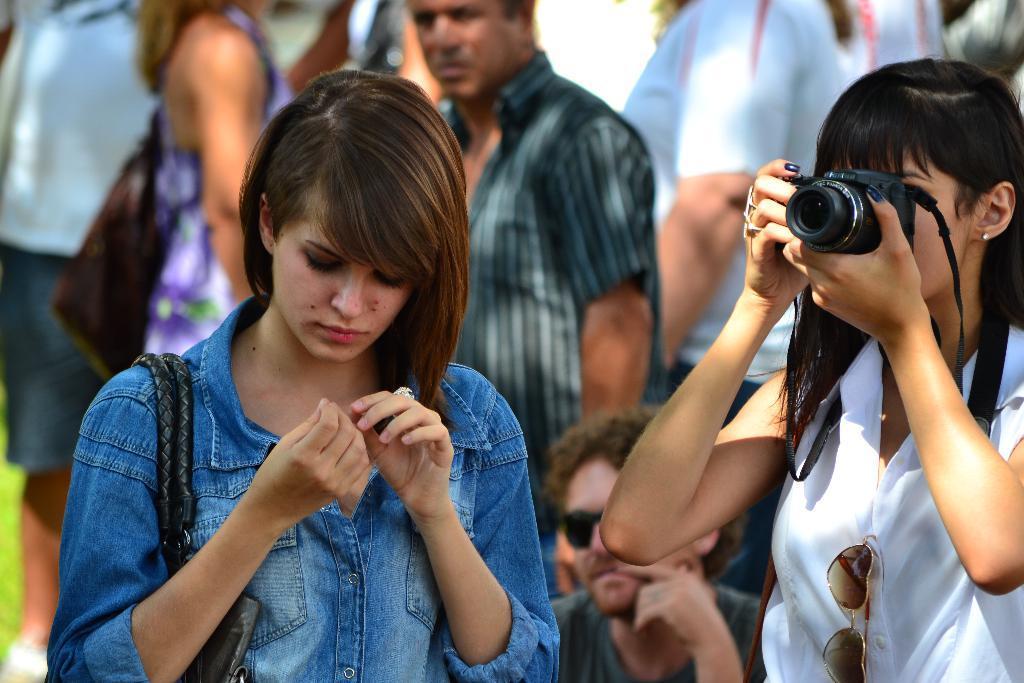Please provide a concise description of this image. In the image we can see there are people who are standing and there is a woman who is holding camera in her hand. 